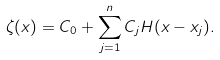Convert formula to latex. <formula><loc_0><loc_0><loc_500><loc_500>\zeta ( x ) = C _ { 0 } + \sum _ { j = 1 } ^ { n } C _ { j } H ( x - x _ { j } ) .</formula> 